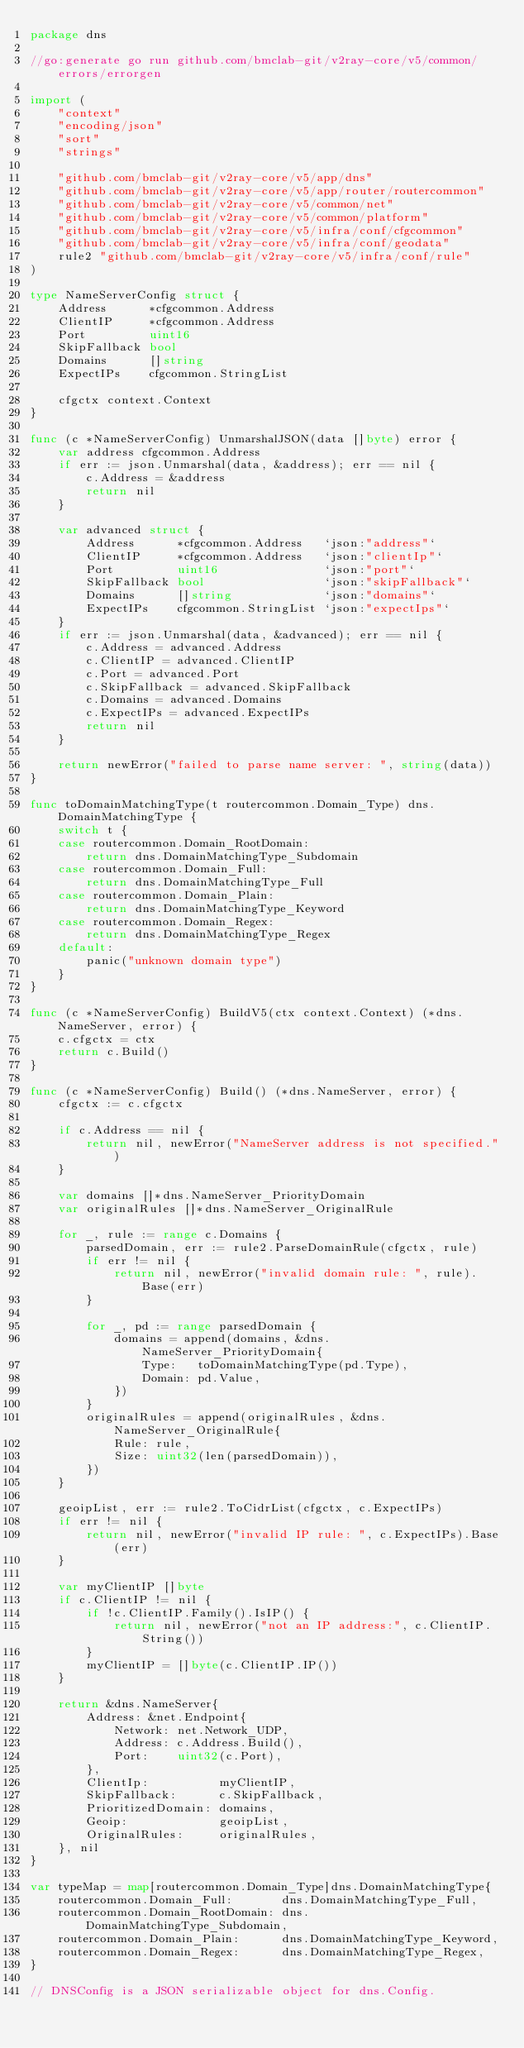Convert code to text. <code><loc_0><loc_0><loc_500><loc_500><_Go_>package dns

//go:generate go run github.com/bmclab-git/v2ray-core/v5/common/errors/errorgen

import (
	"context"
	"encoding/json"
	"sort"
	"strings"

	"github.com/bmclab-git/v2ray-core/v5/app/dns"
	"github.com/bmclab-git/v2ray-core/v5/app/router/routercommon"
	"github.com/bmclab-git/v2ray-core/v5/common/net"
	"github.com/bmclab-git/v2ray-core/v5/common/platform"
	"github.com/bmclab-git/v2ray-core/v5/infra/conf/cfgcommon"
	"github.com/bmclab-git/v2ray-core/v5/infra/conf/geodata"
	rule2 "github.com/bmclab-git/v2ray-core/v5/infra/conf/rule"
)

type NameServerConfig struct {
	Address      *cfgcommon.Address
	ClientIP     *cfgcommon.Address
	Port         uint16
	SkipFallback bool
	Domains      []string
	ExpectIPs    cfgcommon.StringList

	cfgctx context.Context
}

func (c *NameServerConfig) UnmarshalJSON(data []byte) error {
	var address cfgcommon.Address
	if err := json.Unmarshal(data, &address); err == nil {
		c.Address = &address
		return nil
	}

	var advanced struct {
		Address      *cfgcommon.Address   `json:"address"`
		ClientIP     *cfgcommon.Address   `json:"clientIp"`
		Port         uint16               `json:"port"`
		SkipFallback bool                 `json:"skipFallback"`
		Domains      []string             `json:"domains"`
		ExpectIPs    cfgcommon.StringList `json:"expectIps"`
	}
	if err := json.Unmarshal(data, &advanced); err == nil {
		c.Address = advanced.Address
		c.ClientIP = advanced.ClientIP
		c.Port = advanced.Port
		c.SkipFallback = advanced.SkipFallback
		c.Domains = advanced.Domains
		c.ExpectIPs = advanced.ExpectIPs
		return nil
	}

	return newError("failed to parse name server: ", string(data))
}

func toDomainMatchingType(t routercommon.Domain_Type) dns.DomainMatchingType {
	switch t {
	case routercommon.Domain_RootDomain:
		return dns.DomainMatchingType_Subdomain
	case routercommon.Domain_Full:
		return dns.DomainMatchingType_Full
	case routercommon.Domain_Plain:
		return dns.DomainMatchingType_Keyword
	case routercommon.Domain_Regex:
		return dns.DomainMatchingType_Regex
	default:
		panic("unknown domain type")
	}
}

func (c *NameServerConfig) BuildV5(ctx context.Context) (*dns.NameServer, error) {
	c.cfgctx = ctx
	return c.Build()
}

func (c *NameServerConfig) Build() (*dns.NameServer, error) {
	cfgctx := c.cfgctx

	if c.Address == nil {
		return nil, newError("NameServer address is not specified.")
	}

	var domains []*dns.NameServer_PriorityDomain
	var originalRules []*dns.NameServer_OriginalRule

	for _, rule := range c.Domains {
		parsedDomain, err := rule2.ParseDomainRule(cfgctx, rule)
		if err != nil {
			return nil, newError("invalid domain rule: ", rule).Base(err)
		}

		for _, pd := range parsedDomain {
			domains = append(domains, &dns.NameServer_PriorityDomain{
				Type:   toDomainMatchingType(pd.Type),
				Domain: pd.Value,
			})
		}
		originalRules = append(originalRules, &dns.NameServer_OriginalRule{
			Rule: rule,
			Size: uint32(len(parsedDomain)),
		})
	}

	geoipList, err := rule2.ToCidrList(cfgctx, c.ExpectIPs)
	if err != nil {
		return nil, newError("invalid IP rule: ", c.ExpectIPs).Base(err)
	}

	var myClientIP []byte
	if c.ClientIP != nil {
		if !c.ClientIP.Family().IsIP() {
			return nil, newError("not an IP address:", c.ClientIP.String())
		}
		myClientIP = []byte(c.ClientIP.IP())
	}

	return &dns.NameServer{
		Address: &net.Endpoint{
			Network: net.Network_UDP,
			Address: c.Address.Build(),
			Port:    uint32(c.Port),
		},
		ClientIp:          myClientIP,
		SkipFallback:      c.SkipFallback,
		PrioritizedDomain: domains,
		Geoip:             geoipList,
		OriginalRules:     originalRules,
	}, nil
}

var typeMap = map[routercommon.Domain_Type]dns.DomainMatchingType{
	routercommon.Domain_Full:       dns.DomainMatchingType_Full,
	routercommon.Domain_RootDomain: dns.DomainMatchingType_Subdomain,
	routercommon.Domain_Plain:      dns.DomainMatchingType_Keyword,
	routercommon.Domain_Regex:      dns.DomainMatchingType_Regex,
}

// DNSConfig is a JSON serializable object for dns.Config.</code> 